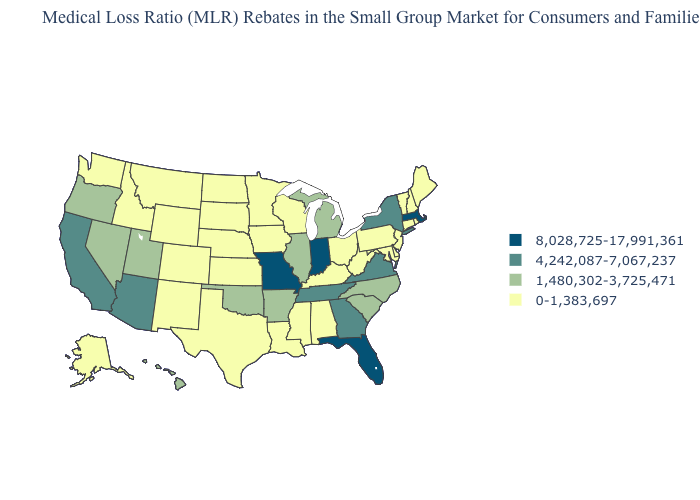What is the value of Arkansas?
Be succinct. 1,480,302-3,725,471. What is the value of Florida?
Answer briefly. 8,028,725-17,991,361. Which states hav the highest value in the Northeast?
Write a very short answer. Massachusetts. Does Idaho have the lowest value in the West?
Keep it brief. Yes. Which states have the lowest value in the USA?
Give a very brief answer. Alabama, Alaska, Colorado, Connecticut, Delaware, Idaho, Iowa, Kansas, Kentucky, Louisiana, Maine, Maryland, Minnesota, Mississippi, Montana, Nebraska, New Hampshire, New Jersey, New Mexico, North Dakota, Ohio, Pennsylvania, Rhode Island, South Dakota, Texas, Vermont, Washington, West Virginia, Wisconsin, Wyoming. What is the highest value in states that border Ohio?
Write a very short answer. 8,028,725-17,991,361. Does Missouri have the highest value in the USA?
Give a very brief answer. Yes. What is the lowest value in the South?
Short answer required. 0-1,383,697. Name the states that have a value in the range 4,242,087-7,067,237?
Quick response, please. Arizona, California, Georgia, New York, Tennessee, Virginia. Among the states that border Michigan , does Ohio have the highest value?
Keep it brief. No. Which states have the lowest value in the West?
Be succinct. Alaska, Colorado, Idaho, Montana, New Mexico, Washington, Wyoming. Does Indiana have the highest value in the USA?
Keep it brief. Yes. Does Kansas have a lower value than Alaska?
Write a very short answer. No. Does the first symbol in the legend represent the smallest category?
Be succinct. No. How many symbols are there in the legend?
Be succinct. 4. 